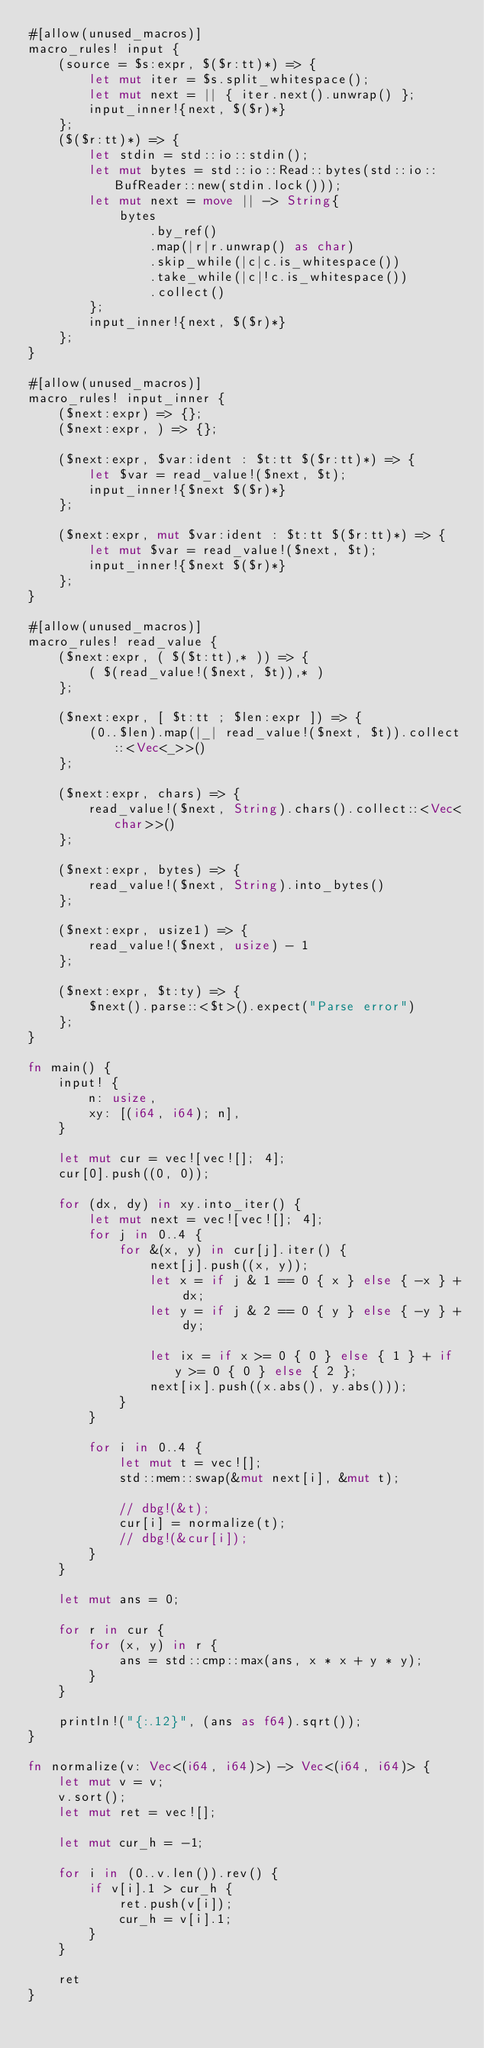Convert code to text. <code><loc_0><loc_0><loc_500><loc_500><_Rust_>#[allow(unused_macros)]
macro_rules! input {
    (source = $s:expr, $($r:tt)*) => {
        let mut iter = $s.split_whitespace();
        let mut next = || { iter.next().unwrap() };
        input_inner!{next, $($r)*}
    };
    ($($r:tt)*) => {
        let stdin = std::io::stdin();
        let mut bytes = std::io::Read::bytes(std::io::BufReader::new(stdin.lock()));
        let mut next = move || -> String{
            bytes
                .by_ref()
                .map(|r|r.unwrap() as char)
                .skip_while(|c|c.is_whitespace())
                .take_while(|c|!c.is_whitespace())
                .collect()
        };
        input_inner!{next, $($r)*}
    };
}

#[allow(unused_macros)]
macro_rules! input_inner {
    ($next:expr) => {};
    ($next:expr, ) => {};

    ($next:expr, $var:ident : $t:tt $($r:tt)*) => {
        let $var = read_value!($next, $t);
        input_inner!{$next $($r)*}
    };

    ($next:expr, mut $var:ident : $t:tt $($r:tt)*) => {
        let mut $var = read_value!($next, $t);
        input_inner!{$next $($r)*}
    };
}

#[allow(unused_macros)]
macro_rules! read_value {
    ($next:expr, ( $($t:tt),* )) => {
        ( $(read_value!($next, $t)),* )
    };

    ($next:expr, [ $t:tt ; $len:expr ]) => {
        (0..$len).map(|_| read_value!($next, $t)).collect::<Vec<_>>()
    };

    ($next:expr, chars) => {
        read_value!($next, String).chars().collect::<Vec<char>>()
    };

    ($next:expr, bytes) => {
        read_value!($next, String).into_bytes()
    };

    ($next:expr, usize1) => {
        read_value!($next, usize) - 1
    };

    ($next:expr, $t:ty) => {
        $next().parse::<$t>().expect("Parse error")
    };
}

fn main() {
    input! {
        n: usize,
        xy: [(i64, i64); n],
    }

    let mut cur = vec![vec![]; 4];
    cur[0].push((0, 0));

    for (dx, dy) in xy.into_iter() {
        let mut next = vec![vec![]; 4];
        for j in 0..4 {
            for &(x, y) in cur[j].iter() {
                next[j].push((x, y));
                let x = if j & 1 == 0 { x } else { -x } + dx;
                let y = if j & 2 == 0 { y } else { -y } + dy;

                let ix = if x >= 0 { 0 } else { 1 } + if y >= 0 { 0 } else { 2 };
                next[ix].push((x.abs(), y.abs()));
            }
        }

        for i in 0..4 {
            let mut t = vec![];
            std::mem::swap(&mut next[i], &mut t);

            // dbg!(&t);
            cur[i] = normalize(t);
            // dbg!(&cur[i]);
        }
    }

    let mut ans = 0;

    for r in cur {
        for (x, y) in r {
            ans = std::cmp::max(ans, x * x + y * y);
        }
    }

    println!("{:.12}", (ans as f64).sqrt());
}

fn normalize(v: Vec<(i64, i64)>) -> Vec<(i64, i64)> {
    let mut v = v;
    v.sort();
    let mut ret = vec![];

    let mut cur_h = -1;

    for i in (0..v.len()).rev() {
        if v[i].1 > cur_h {
            ret.push(v[i]);
            cur_h = v[i].1;
        }
    }

    ret
}
</code> 